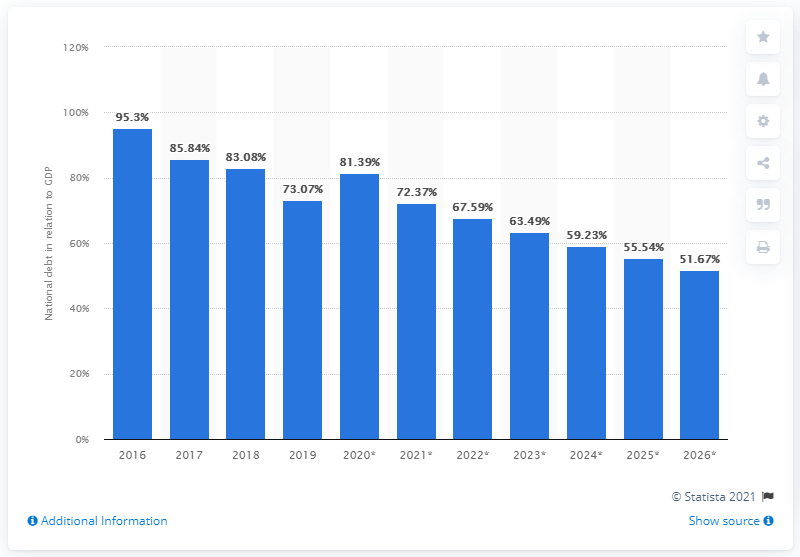Indicate a few pertinent items in this graphic. In 2019, the national debt of São Tomé and Príncipe was approximately 72.37% of the country's GDP. 